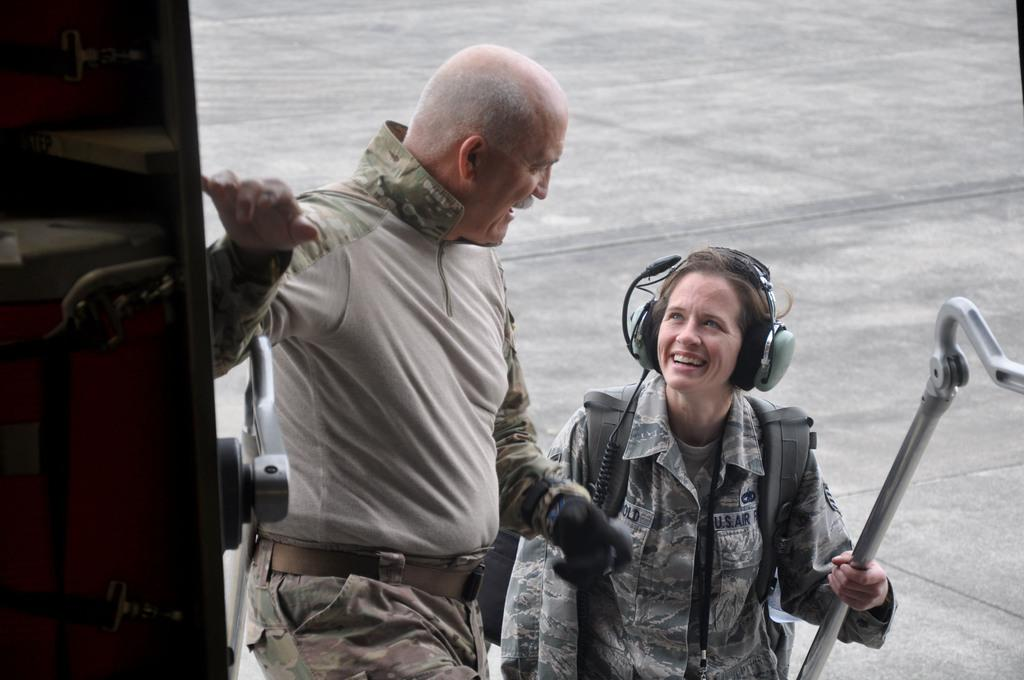What are the people in the image wearing? The people in the image are wearing uniforms. Can you describe any specific accessories worn by the people? One person is wearing a headset, and another person is wearing a bag. What is one person holding in the image? One person is holding a rod. What is visible in the background of the image? There is a door and a road visible in the image. What type of toothpaste is being used by the person wearing the headset in the image? There is no toothpaste present in the image; it features people wearing uniforms, some with accessories, and a door and road in the background. 